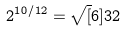Convert formula to latex. <formula><loc_0><loc_0><loc_500><loc_500>2 ^ { 1 0 / 1 2 } = \sqrt { [ } 6 ] { 3 2 }</formula> 